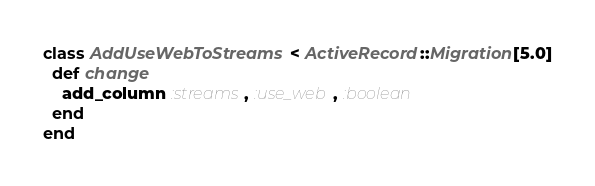<code> <loc_0><loc_0><loc_500><loc_500><_Ruby_>class AddUseWebToStreams < ActiveRecord::Migration[5.0]
  def change
    add_column :streams, :use_web, :boolean
  end
end
</code> 